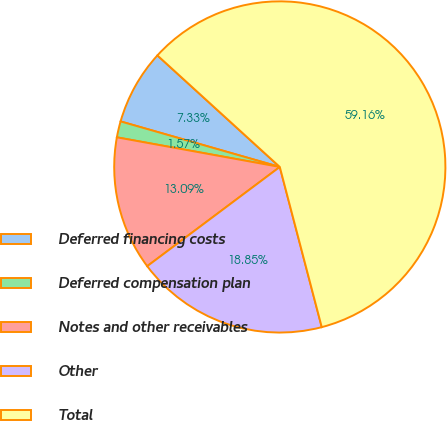Convert chart to OTSL. <chart><loc_0><loc_0><loc_500><loc_500><pie_chart><fcel>Deferred financing costs<fcel>Deferred compensation plan<fcel>Notes and other receivables<fcel>Other<fcel>Total<nl><fcel>7.33%<fcel>1.57%<fcel>13.09%<fcel>18.85%<fcel>59.16%<nl></chart> 